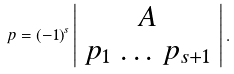Convert formula to latex. <formula><loc_0><loc_0><loc_500><loc_500>p = ( - 1 ) ^ { s } \left | \begin{array} { c } A \\ p _ { 1 } \, \dots \, p _ { s + 1 } \end{array} \right | .</formula> 